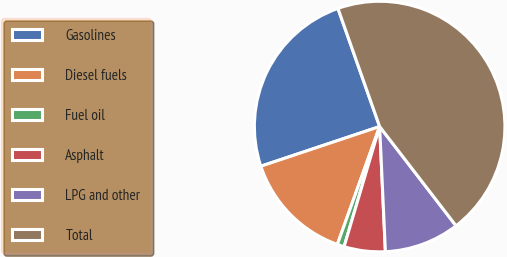Convert chart. <chart><loc_0><loc_0><loc_500><loc_500><pie_chart><fcel>Gasolines<fcel>Diesel fuels<fcel>Fuel oil<fcel>Asphalt<fcel>LPG and other<fcel>Total<nl><fcel>24.73%<fcel>14.39%<fcel>0.9%<fcel>5.31%<fcel>9.71%<fcel>44.96%<nl></chart> 